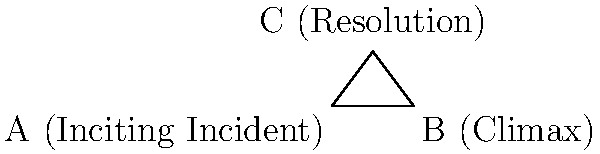In the plot structure triangle ABC, where A represents the Inciting Incident, B the Climax, and C the Resolution, angle ACB is a right angle. If the length of AB (representing the main conflict) is 6 units and the height of the triangle (AC) is 4 units, what is the measure of angle CAB ($\theta$) in degrees? This angle represents the rate at which conflict escalates in your Christian fiction novel. To solve this problem, we'll use trigonometry in the right triangle ACB:

1) We know that AB = 6 units and AC = 4 units.

2) In a right triangle, $\tan \theta = \frac{\text{opposite}}{\text{adjacent}}$.

3) In this case, $\tan \theta = \frac{AC}{CB} = \frac{4}{CB}$.

4) We need to find CB. We can use the Pythagorean theorem:
   $AB^2 = AC^2 + CB^2$
   $6^2 = 4^2 + CB^2$
   $36 = 16 + CB^2$
   $CB^2 = 20$
   $CB = \sqrt{20} \approx 4.47$ units

5) Now we can calculate $\tan \theta$:
   $\tan \theta = \frac{4}{4.47} \approx 0.8944$

6) To find $\theta$, we take the inverse tangent (arctan):
   $\theta = \arctan(0.8944) \approx 41.81$ degrees

This angle represents how quickly the conflict escalates from the Inciting Incident towards the Climax in your Christian fiction novel's plot structure.
Answer: $41.81^\circ$ 